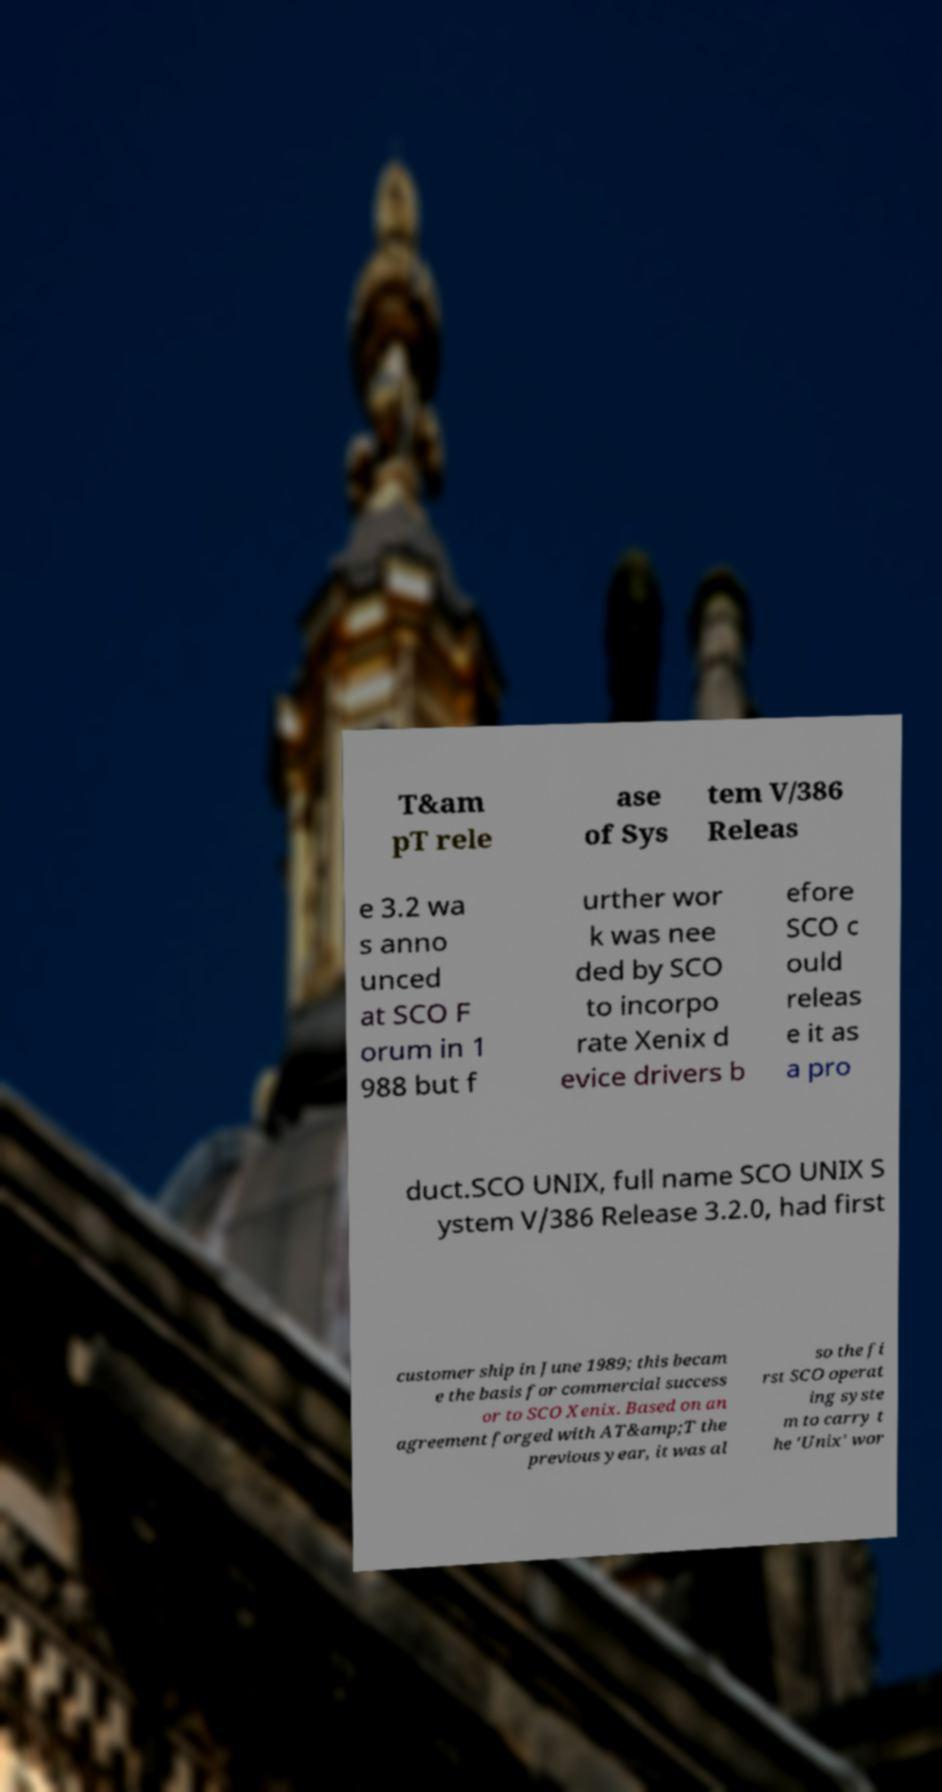Can you read and provide the text displayed in the image?This photo seems to have some interesting text. Can you extract and type it out for me? T&am pT rele ase of Sys tem V/386 Releas e 3.2 wa s anno unced at SCO F orum in 1 988 but f urther wor k was nee ded by SCO to incorpo rate Xenix d evice drivers b efore SCO c ould releas e it as a pro duct.SCO UNIX, full name SCO UNIX S ystem V/386 Release 3.2.0, had first customer ship in June 1989; this becam e the basis for commercial success or to SCO Xenix. Based on an agreement forged with AT&amp;T the previous year, it was al so the fi rst SCO operat ing syste m to carry t he 'Unix' wor 